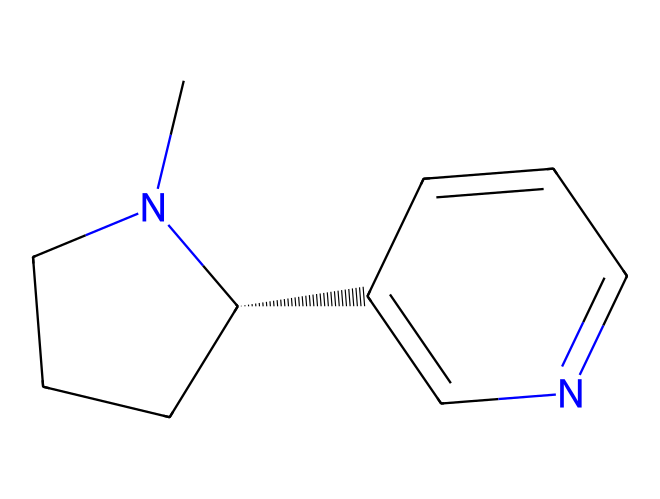What is the molecular formula of nicotine? To find the molecular formula, we count the number of each type of atom present in the SMILES representation. From the SMILES CN1CCC[C@H]1C2=CN=CC=C2, we identify the atoms: C (carbon), H (hydrogen), and N (nitrogen). The count is as follows: 10 carbon atoms, 14 hydrogen atoms, and 2 nitrogen atoms, resulting in the formula C10H14N2.
Answer: C10H14N2 How many nitrogen atoms are in nicotine? By analyzing the SMILES representation, we can spot the nitrogen symbols "N." There are two instances of "N" in the structure, indicating the presence of 2 nitrogen atoms.
Answer: 2 What type of compound is nicotine classified as? Nicotine has a structure that includes a pyridine and a pyrrolidine ring, classifying it as an alkaloid, which are natural compounds that contain basic nitrogen atoms.
Answer: alkaloid What kind of rings are present in the structure of nicotine? Examining the SMILES formula shows two distinct cyclic structures, a six-membered ring with one nitrogen (pyridine) and a five-membered ring (pyrrolidine). This is characteristic of alkaloids like nicotine.
Answer: pyridine and pyrrolidine Is nicotine a saturated or unsaturated compound? The presence of double bonds in the SMILES representation (depicted by the "=" sign) indicates unsaturation in the carbon chain. Therefore, nicotine is classified as an unsaturated compound due to the existence of these double bonds.
Answer: unsaturated What role do nitrogen atoms play in the nicotine structure? The nitrogen atoms present in nicotine contribute to its basicity and its ability to form hydrogen bonds. This impacts the behavior of nicotine in biological systems, making it a significant neurotransmitter.
Answer: basicity and hydrogen bonding 